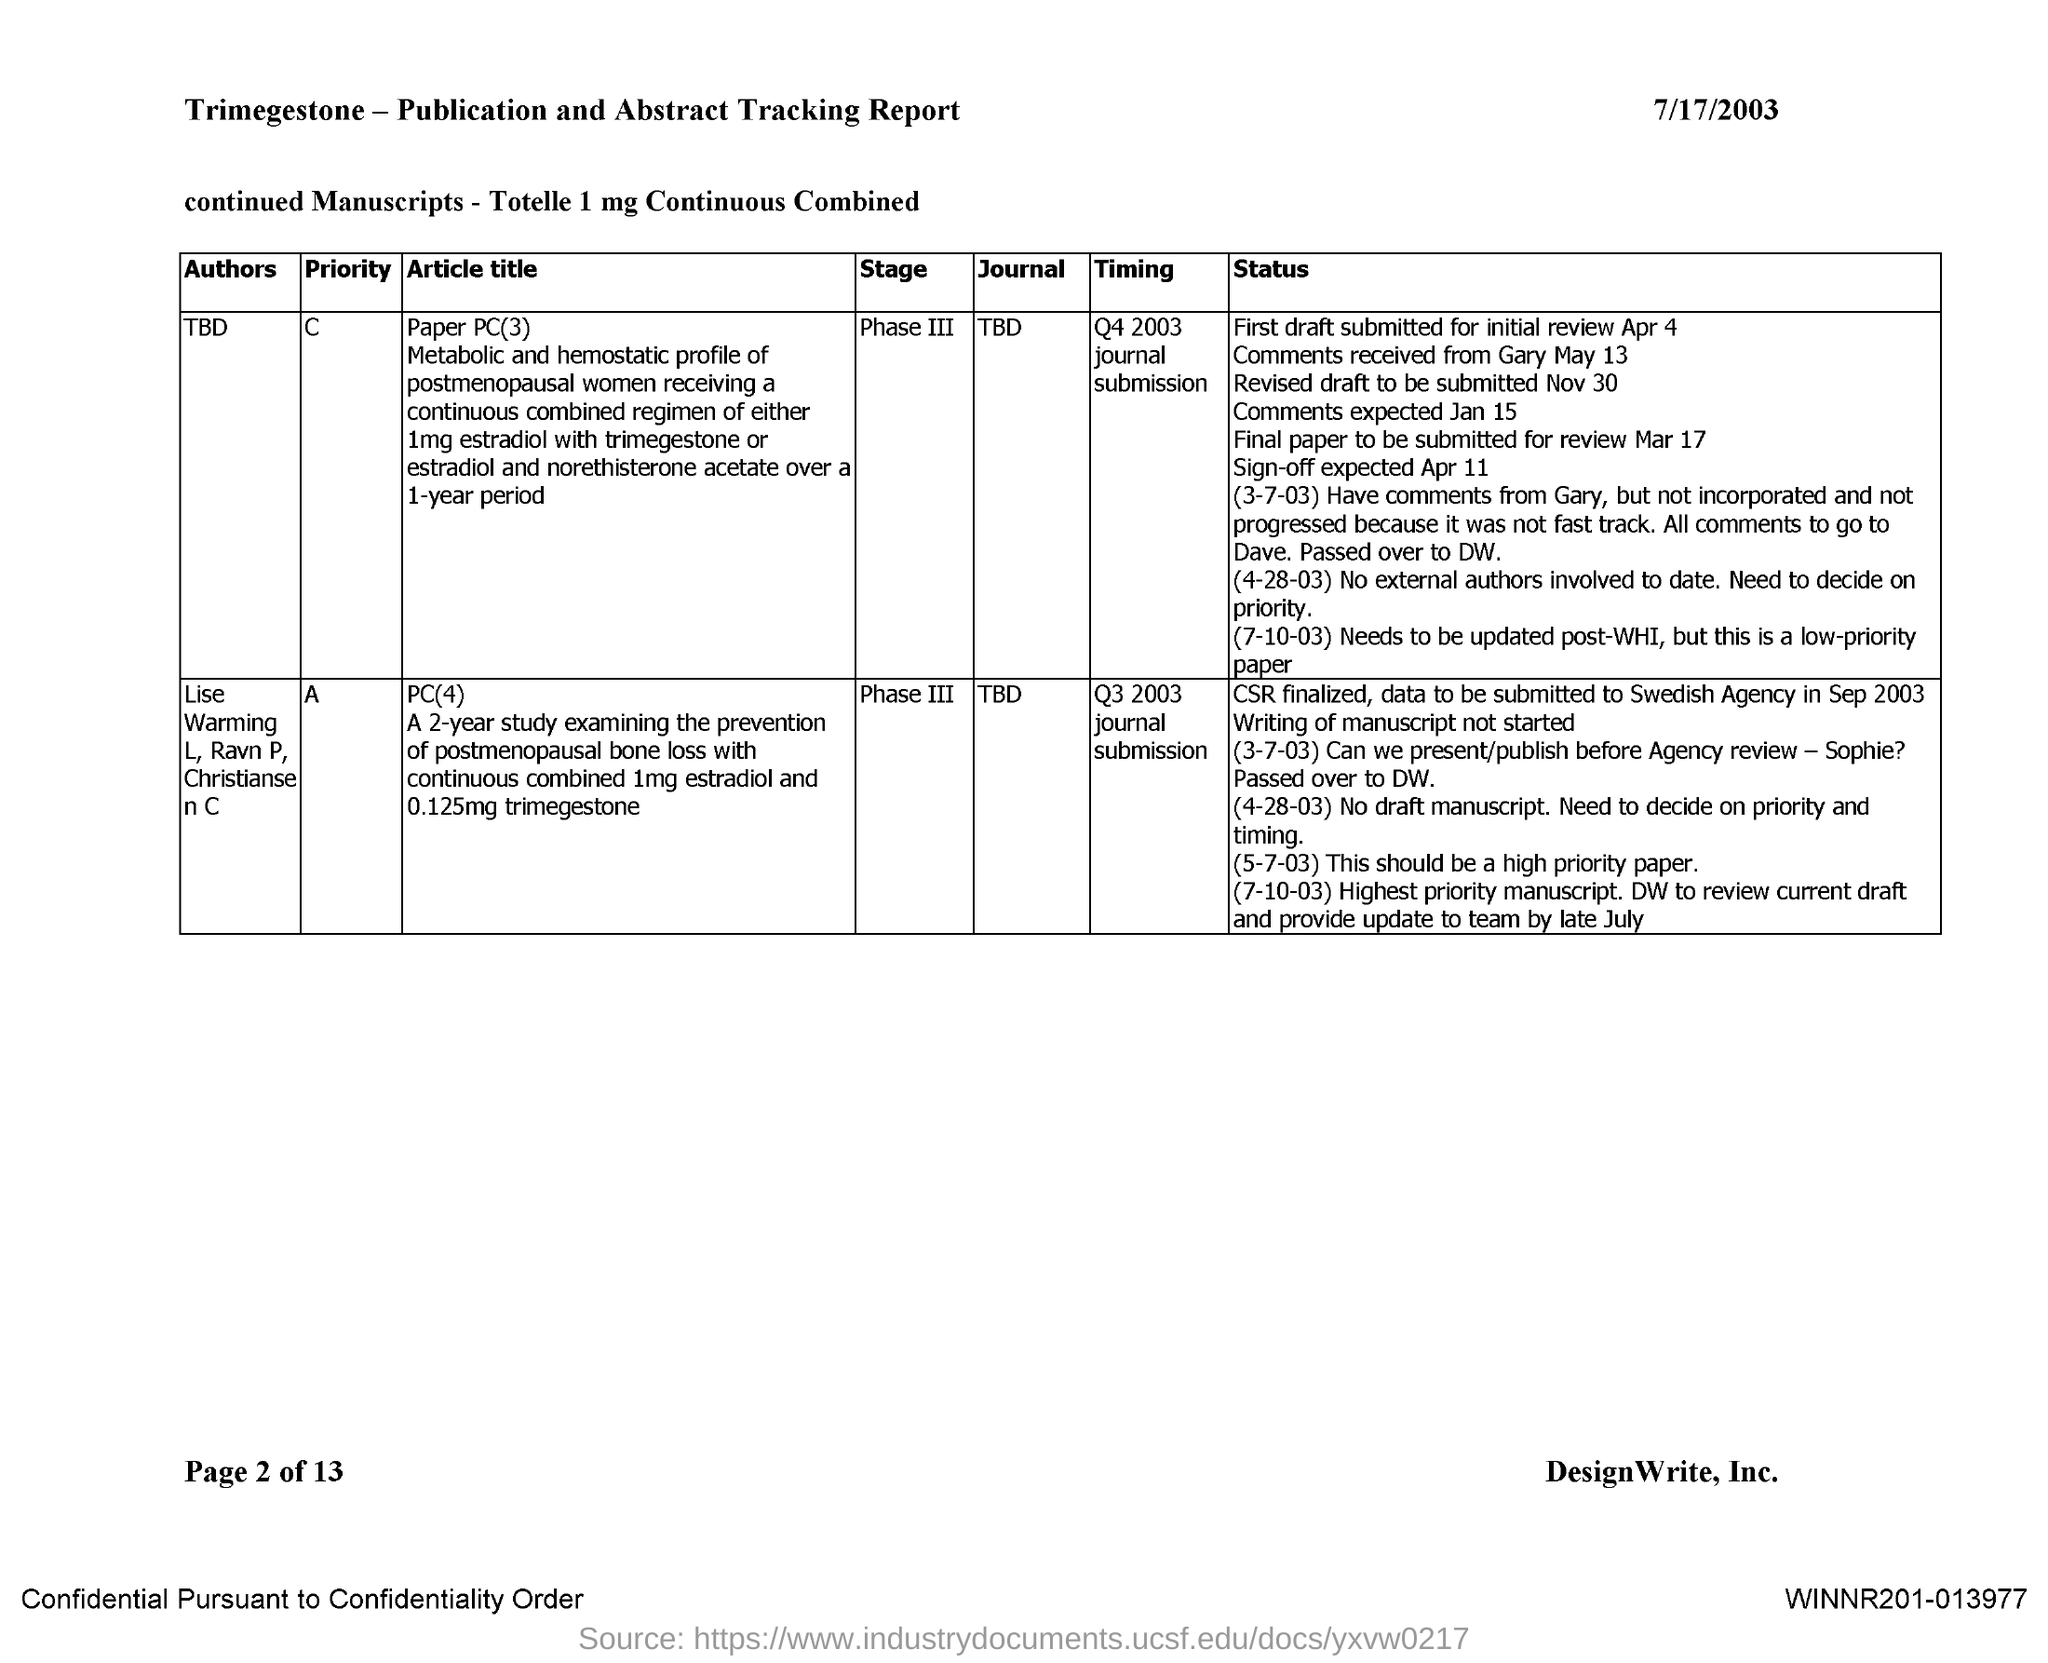List a handful of essential elements in this visual. The current stage of the journal with priority "A" is phase III. The current stage of the journal with priority "C" is Phase III. The name of the journal with priority 'C' has yet to be determined. The name of the author of the journal with priority "C" is currently unknown. The authors of the journal with priority 'A' are Lise Warming L, Ravn P, and Christiansen C. 